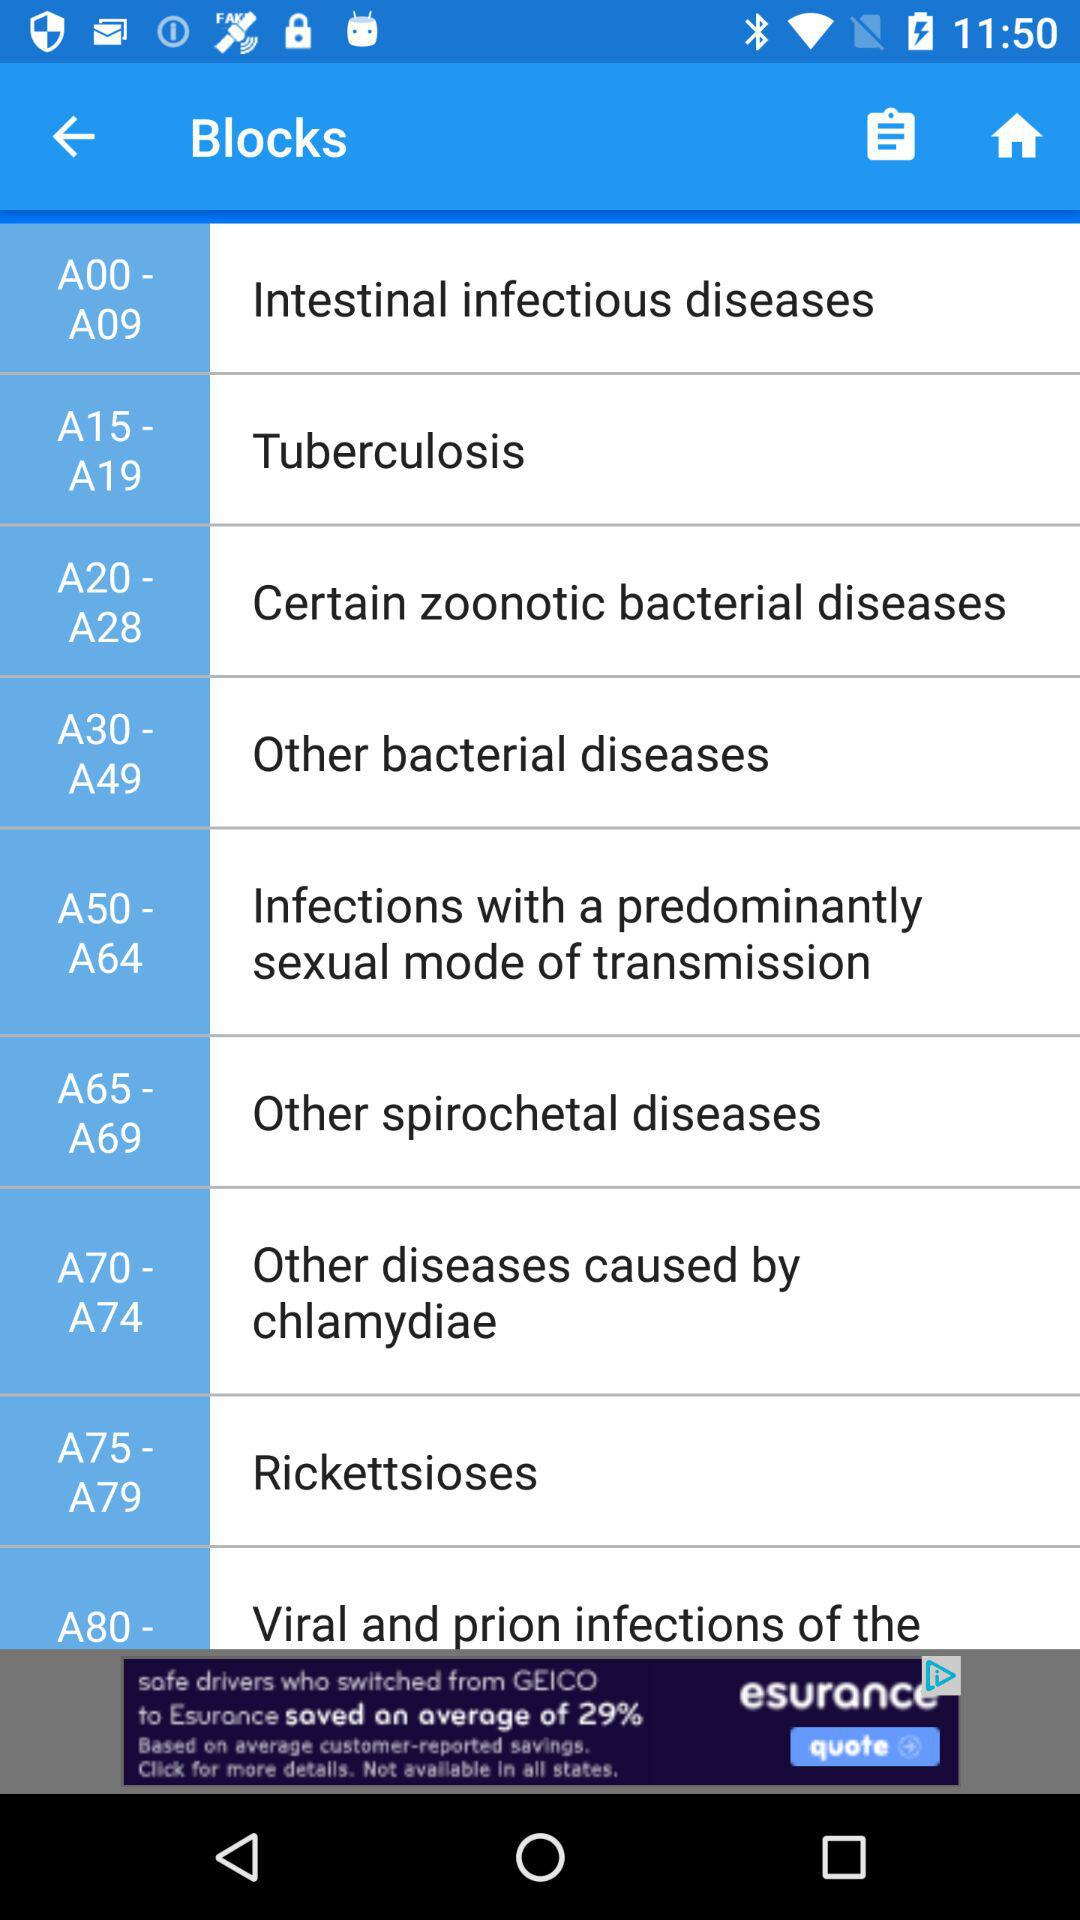Which disease is contained in blocks A00–A09? The diseases that are contained in blocks A00–A09 are intestinal infectious diseases. 